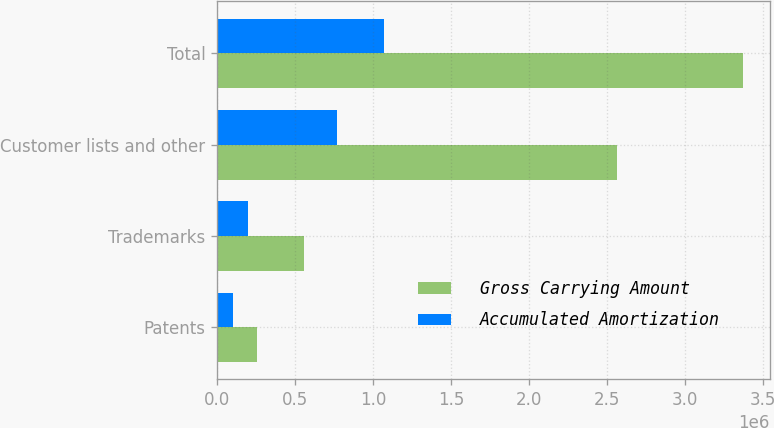<chart> <loc_0><loc_0><loc_500><loc_500><stacked_bar_chart><ecel><fcel>Patents<fcel>Trademarks<fcel>Customer lists and other<fcel>Total<nl><fcel>Gross Carrying Amount<fcel>254049<fcel>553691<fcel>2.56698e+06<fcel>3.37472e+06<nl><fcel>Accumulated Amortization<fcel>100860<fcel>200413<fcel>765966<fcel>1.06724e+06<nl></chart> 